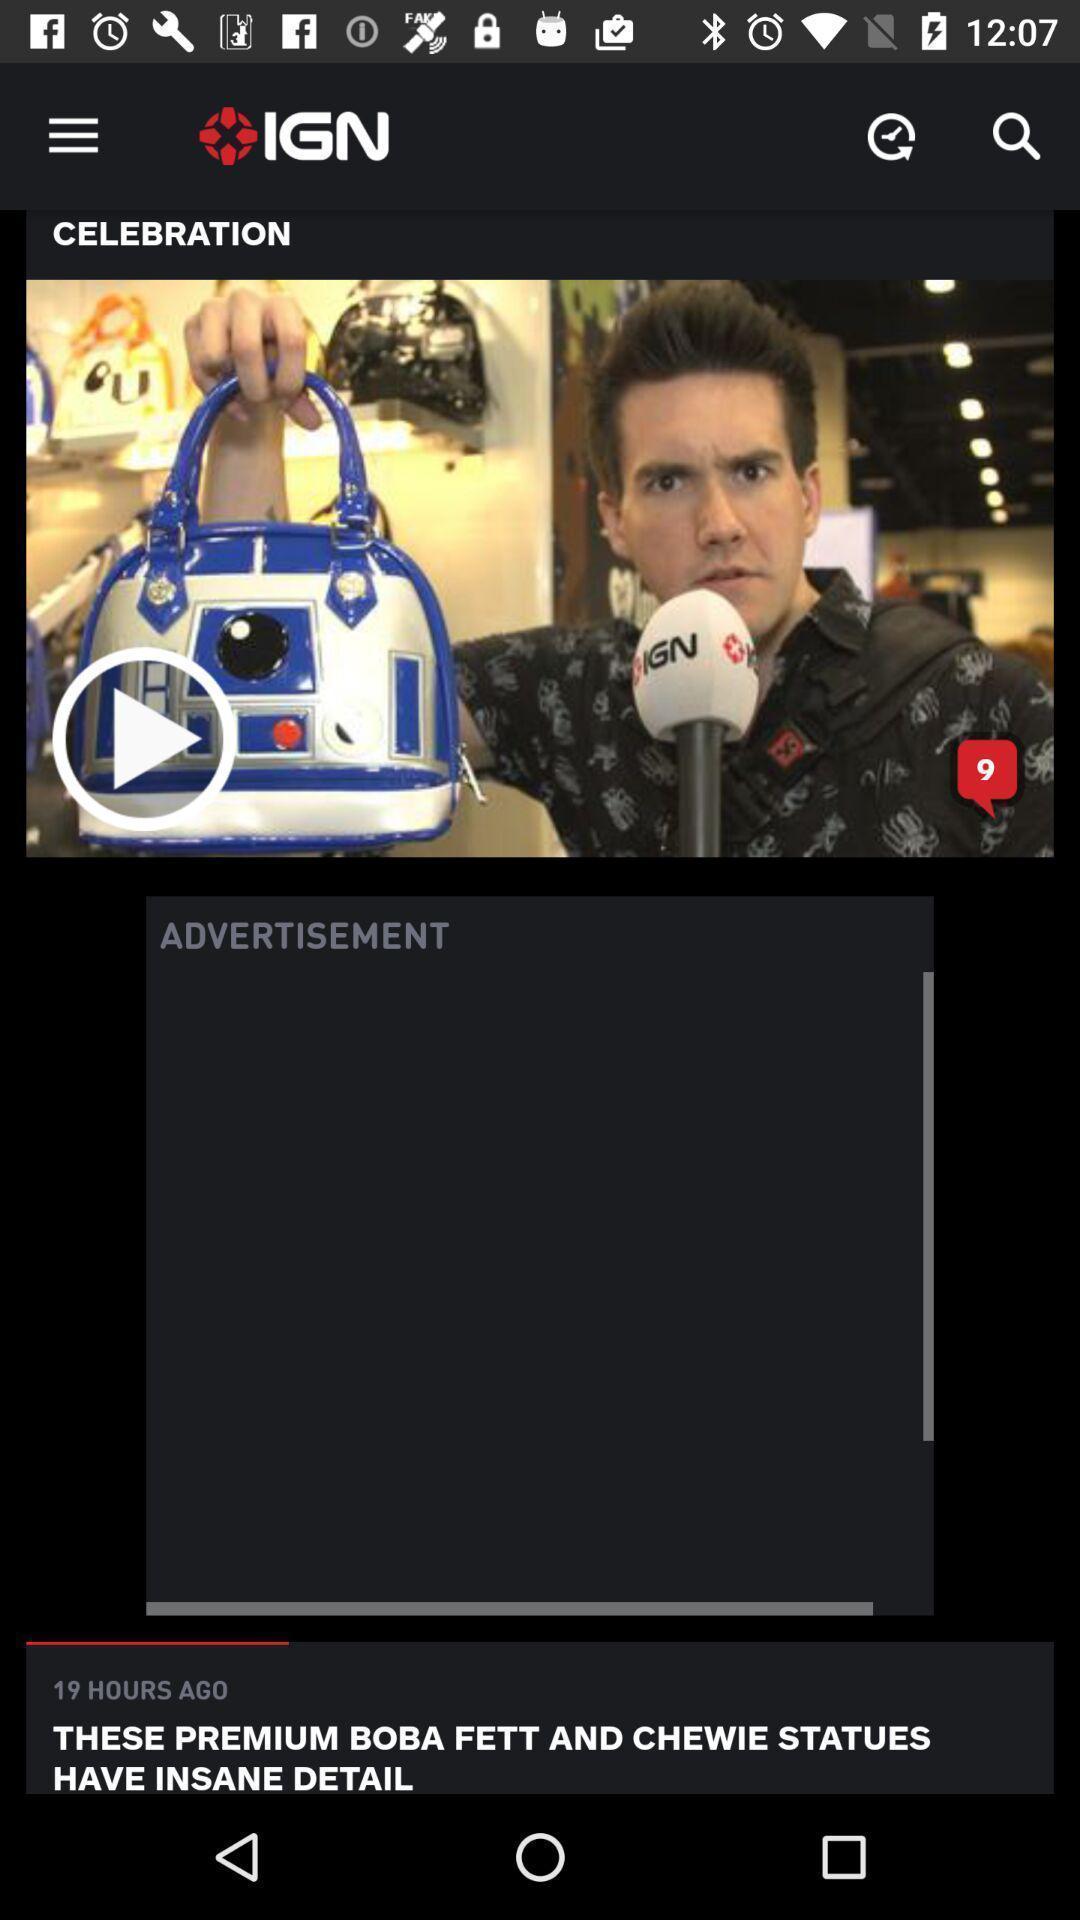Please provide a description for this image. Screen shows a video games app. 